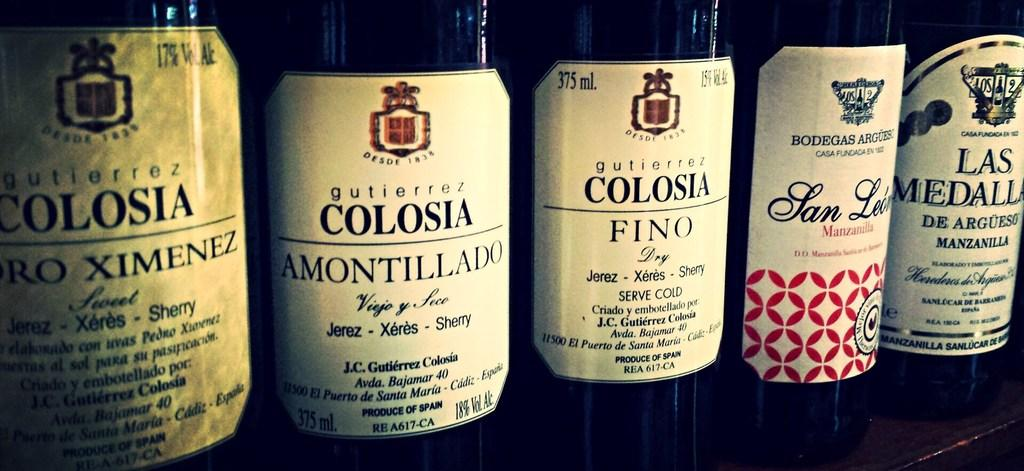<image>
Create a compact narrative representing the image presented. An assortment of five wine bottles with Colosia on three of the labels. 